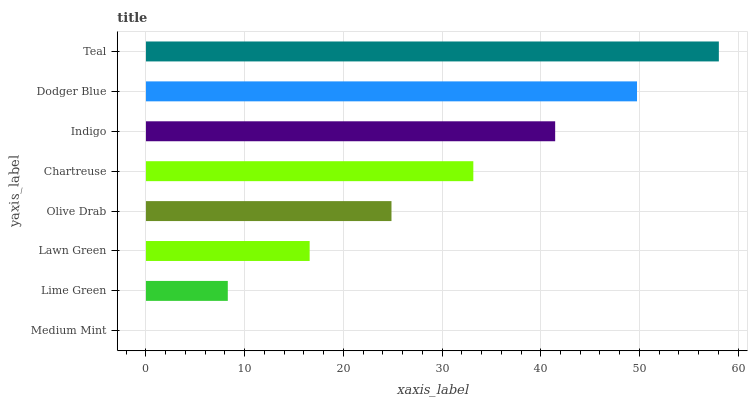Is Medium Mint the minimum?
Answer yes or no. Yes. Is Teal the maximum?
Answer yes or no. Yes. Is Lime Green the minimum?
Answer yes or no. No. Is Lime Green the maximum?
Answer yes or no. No. Is Lime Green greater than Medium Mint?
Answer yes or no. Yes. Is Medium Mint less than Lime Green?
Answer yes or no. Yes. Is Medium Mint greater than Lime Green?
Answer yes or no. No. Is Lime Green less than Medium Mint?
Answer yes or no. No. Is Chartreuse the high median?
Answer yes or no. Yes. Is Olive Drab the low median?
Answer yes or no. Yes. Is Medium Mint the high median?
Answer yes or no. No. Is Lawn Green the low median?
Answer yes or no. No. 